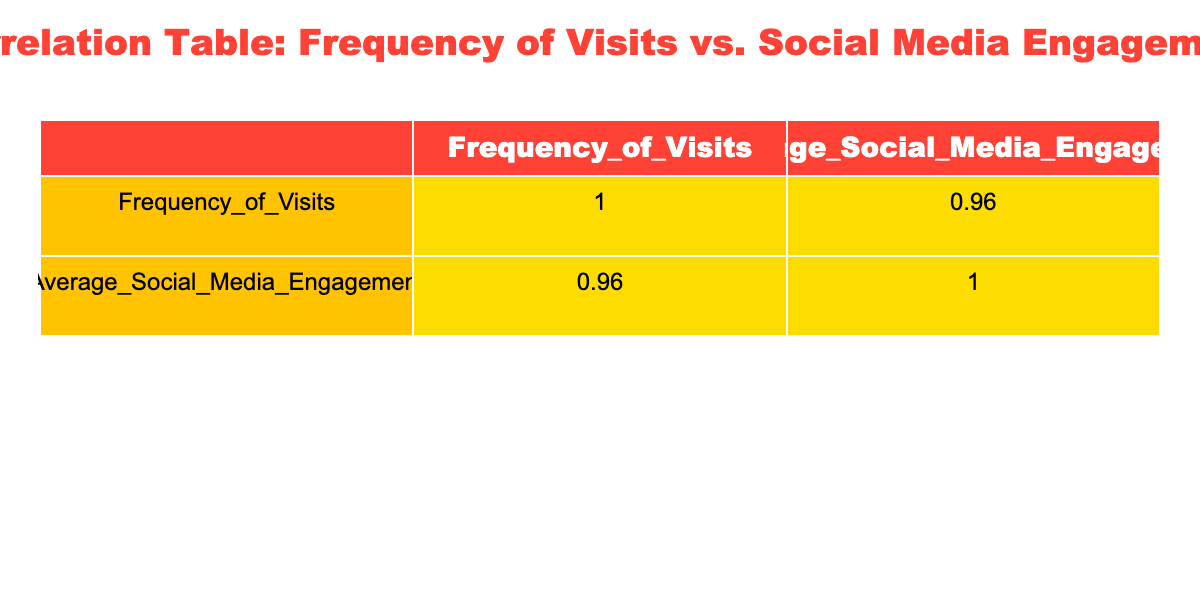What is the correlation coefficient between the frequency of visits and average social media engagement? The correlation coefficient is found in the correlation table, specifically in the cell that intersects the row and column for 'Frequency_of_Visits' and 'Average_Social_Media_Engagement'.
Answer: 0.95 Which movie genre is associated with the highest average social media engagement? To find this, I look for the row with the maximum value in the 'Average_Social_Media_Engagement' column, which is 300. This engagement corresponds to the 'Action' genre in the same row.
Answer: Action What is the average social media engagement for those who visit Cinépolis 2 times? There is one instance of a frequency of visits equal to 2, which has an average social media engagement of 150. Therefore, the average is 150.
Answer: 150 Is there a relationship between visiting frequency and social media engagement that can be considered strong? Looking at the correlation coefficient value of 0.95, this indicates a strong positive relationship since it is close to 1.
Answer: Yes If a person visits Cinépolis 4 times, what is the average social media engagement for that frequency? There is one row where the frequency of visits is 4. The 'Average_Social_Media_Engagement' for that entry is 220. Therefore, it is directly read from the table.
Answer: 220 What is the percentage increase in social media engagement from those who visit 1 time to those who visit 5 times? For 1 visit, the engagement is 100, and for 5 visits, it is 300. The increase equals (300 - 100) / 100 * 100% = 200%.
Answer: 200% Is it true that people in the age group 25-34 visited Cinépolis only once? In the table, only one record corresponds to the age group 25-34 with a frequency of 1 visit, confirming it's true.
Answer: Yes What is the total average social media engagement for visitors aged 18-24 who favor the Action genre? There are two rows with frequency 1 and 4 for the Action genre, yielding engagements of 100 and 220. The average for these values = (100 + 220) / 2 = 160.
Answer: 160 